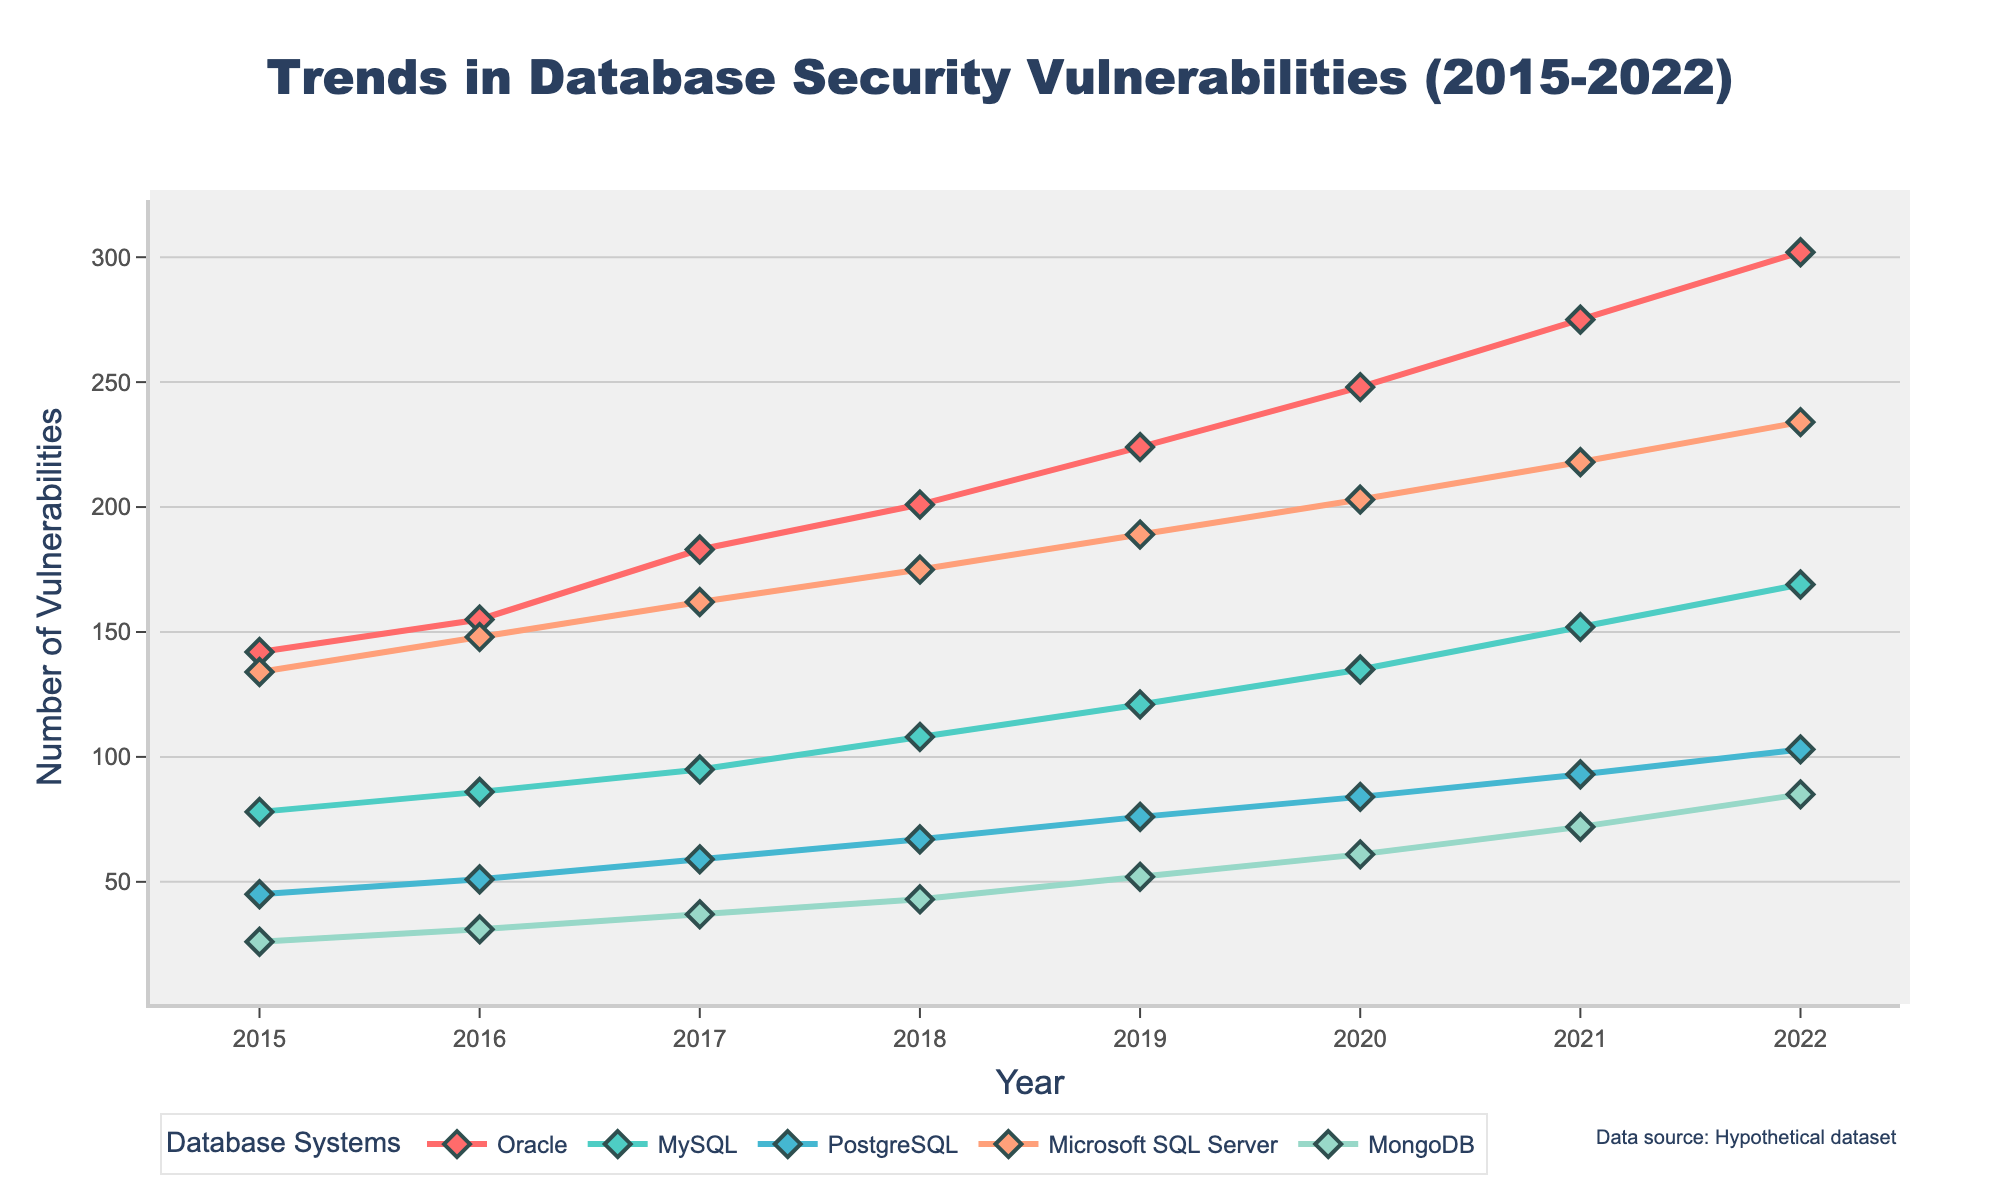What's the trend of security vulnerabilities reported in Oracle from 2015 to 2022? To determine the trend, observe the line representing Oracle from 2015 to 2022. The line shows an increasing trend starting from 142 in 2015 and reaching 302 in 2022.
Answer: Increasing Which database had the lowest number of vulnerabilities in 2018? Review the y-values for all databases in 2018. MongoDB has the lowest number of vulnerabilities with 43 incidents.
Answer: MongoDB In which year did Microsoft SQL Server exceed 200 reported vulnerabilities for the first time? Check the line corresponding to Microsoft SQL Server. It first exceeds 200 reported vulnerabilities in 2020.
Answer: 2020 How many total security vulnerabilities were reported across all databases in 2019? Sum up the vulnerabilities for each database in 2019: Oracle (224) + MySQL (121) + PostgreSQL (76) + Microsoft SQL Server (189) + MongoDB (52). The total is 224 + 121 + 76 + 189 + 52 = 662.
Answer: 662 Which database system had the highest increase in vulnerabilities between consecutive years? Calculate the year-over-year increase for each database from one year to the next. The highest increase is observed in Oracle from 2021 (275) to 2022 (302) with an increase of 27 vulnerabilities.
Answer: Oracle Which database had the consistent upward trend in reported vulnerabilities over the entire period from 2015 to 2022? Analyze the lines representing each database to determine consistency in an upward trend. All databases show consistent upward trends; however, Oracle shows a clear and steady increase each year.
Answer: Oracle Compare the number of vulnerabilities reported for PostgreSQL and MySQL in 2017. Which one was higher and by how much? Check the points for both PostgreSQL (59) and MySQL (95) in 2017. MySQL has higher vulnerabilities. Subtract the PostgreSQL value from the MySQL value: 95 - 59 = 36.
Answer: MySQL by 36 Which year shows the largest gap between the number of vulnerabilities reported in MySQL and MongoDB? By comparing the differences each year, 2022 has the largest gap between MySQL (169) and MongoDB (85), with a difference of 169 - 85 = 84.
Answer: 2022 In 2022, what is the average number of vulnerabilities reported across all databases? Sum up the vulnerabilities for each database in 2022 (302 + 169 + 103 + 234 + 85) = 893. Then divide by the number of databases: 893 / 5 = 178.6.
Answer: 178.6 What is the overall trend in the total number of vulnerabilities reported annually across all databases? Sum the vulnerabilities for each year and observe their progression: 425 (2015), 471 (2016), 536 (2017), 594 (2018), 662 (2019), 731 (2020), 810 (2021), 893 (2022). The totals indicate a general increasing trend.
Answer: Increasing 